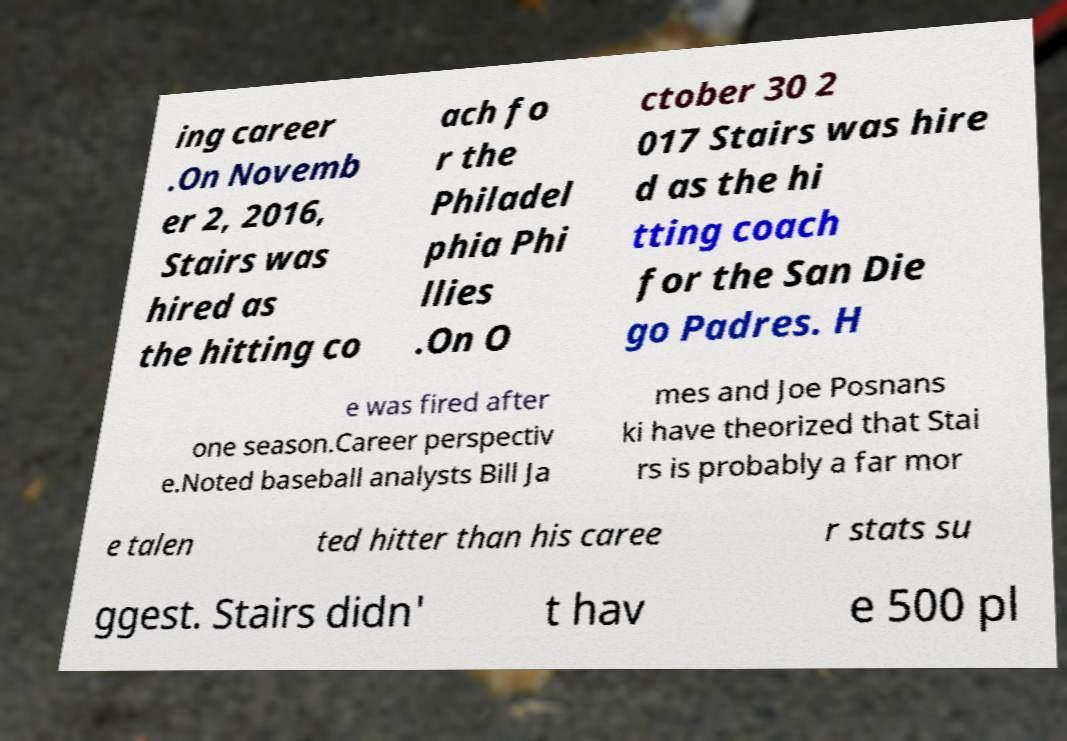There's text embedded in this image that I need extracted. Can you transcribe it verbatim? ing career .On Novemb er 2, 2016, Stairs was hired as the hitting co ach fo r the Philadel phia Phi llies .On O ctober 30 2 017 Stairs was hire d as the hi tting coach for the San Die go Padres. H e was fired after one season.Career perspectiv e.Noted baseball analysts Bill Ja mes and Joe Posnans ki have theorized that Stai rs is probably a far mor e talen ted hitter than his caree r stats su ggest. Stairs didn' t hav e 500 pl 